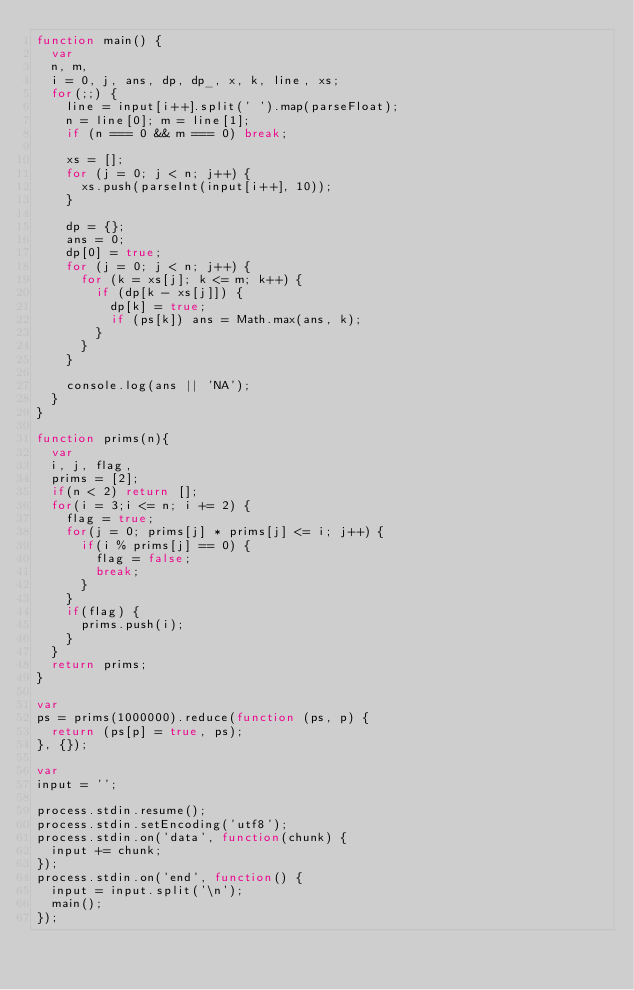Convert code to text. <code><loc_0><loc_0><loc_500><loc_500><_JavaScript_>function main() {
  var
  n, m,
  i = 0, j, ans, dp, dp_, x, k, line, xs;
  for(;;) {
    line = input[i++].split(' ').map(parseFloat);
    n = line[0]; m = line[1];
    if (n === 0 && m === 0) break;
    
    xs = [];
    for (j = 0; j < n; j++) {
      xs.push(parseInt(input[i++], 10));
    }
    
    dp = {};
    ans = 0;
    dp[0] = true;
    for (j = 0; j < n; j++) {
      for (k = xs[j]; k <= m; k++) {
        if (dp[k - xs[j]]) {
          dp[k] = true;
          if (ps[k]) ans = Math.max(ans, k);
        }
      }
    }

    console.log(ans || 'NA');
  }
}

function prims(n){
  var
  i, j, flag,
  prims = [2];
  if(n < 2) return [];
  for(i = 3;i <= n; i += 2) {
    flag = true;
    for(j = 0; prims[j] * prims[j] <= i; j++) {
      if(i % prims[j] == 0) {
        flag = false;
        break;
      }
    }
    if(flag) {
      prims.push(i);
    }
  }
  return prims;
}

var
ps = prims(1000000).reduce(function (ps, p) {
  return (ps[p] = true, ps);
}, {});

var
input = '';

process.stdin.resume();
process.stdin.setEncoding('utf8');
process.stdin.on('data', function(chunk) {
  input += chunk;
});
process.stdin.on('end', function() {
  input = input.split('\n');
  main();
});</code> 